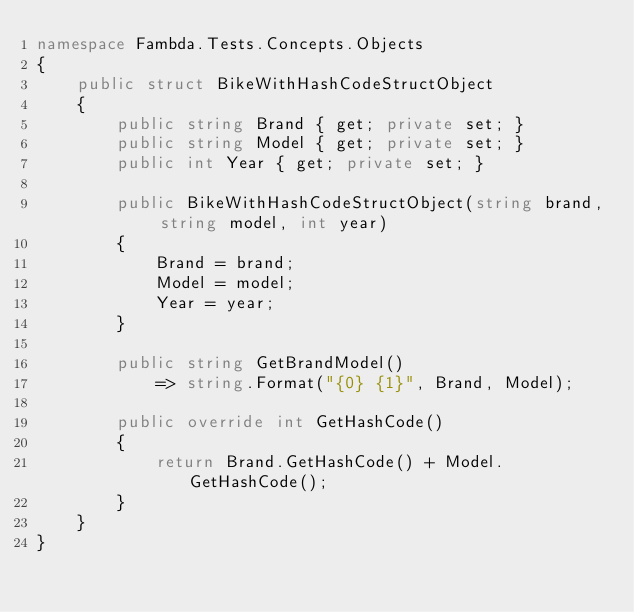Convert code to text. <code><loc_0><loc_0><loc_500><loc_500><_C#_>namespace Fambda.Tests.Concepts.Objects
{
    public struct BikeWithHashCodeStructObject
    {
        public string Brand { get; private set; }
        public string Model { get; private set; }
        public int Year { get; private set; }

        public BikeWithHashCodeStructObject(string brand, string model, int year)
        {
            Brand = brand;
            Model = model;
            Year = year;
        }

        public string GetBrandModel()
            => string.Format("{0} {1}", Brand, Model);

        public override int GetHashCode()
        {
            return Brand.GetHashCode() + Model.GetHashCode();
        }
    }
}
</code> 